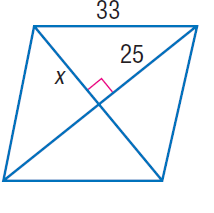Question: Find x.
Choices:
A. 4 \sqrt { 29 }
B. 25
C. 33
D. \sqrt { 1714 }
Answer with the letter. Answer: A 